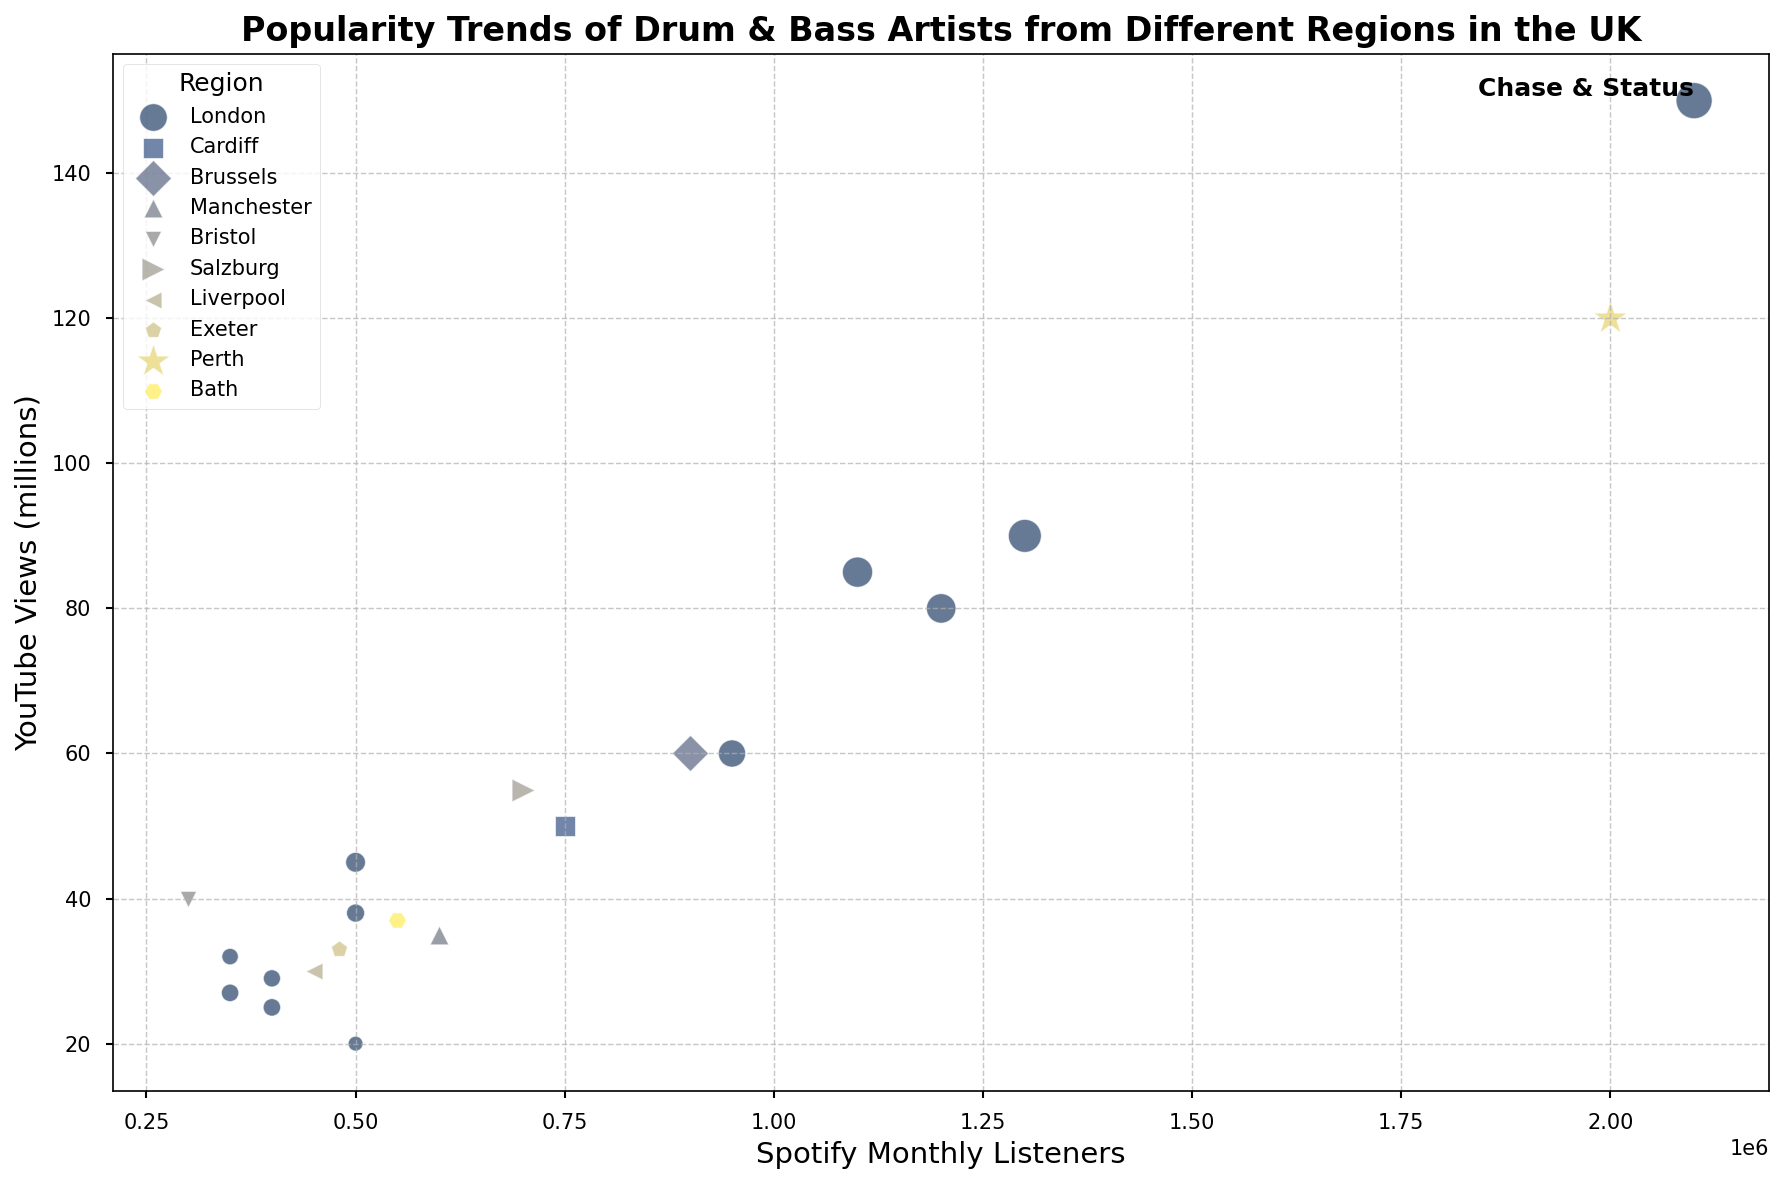What is the total number of Spotify Monthly Listeners for artists from London? First, identify all the artists from London. Their Spotify Monthly Listeners are: Chase & Status (2,100,000), Sub Focus (1,200,000), Hospital Records (500,000), Fabio & Grooverider (400,000), Goldie (500,000), Brookes Brothers (350,000), Wilkinson (1,300,000), Andy C (1,100,000), DJ Fresh (950,000), LTJ Bukem (350,000), London Elektricity (400,000). Summing these values: 2,100,000 + 1,200,000 + 500,000 + 400,000 + 500,000 + 350,000 + 1,300,000 + 1,100,000 + 950,000 + 350,000 + 400,000 = 9,150,000
Answer: 9,150,000 Which artist has more Instagram Followers, Wilkinson or Pendulum? Check the Instagram Followers for Wilkinson (250,000) and Pendulum (280,000). Compare both values and find that Pendulum has more followers.
Answer: Pendulum Do Chase & Status have more YouTube Views than High Contrast? Compare the YouTube Views for Chase & Status (150 million) and High Contrast (50 million). The value for Chase & Status is greater.
Answer: Yes Which region has the most artists represented in the plot? Identify the regions and count the number of artists from each: London (12), Cardiff (1), Brussels (1), Manchester (1), Bristol (1), Salzburg (1), Liverpool (1), Exeter (1), Bath (1), Perth (1). London has the most artists.
Answer: London What is the average number of Instagram Followers for artists from London? Calculate the total number of Instagram Followers for London artists: 300,000 (Chase & Status) + 200,000 (Sub Focus) + 50,000 (Hospital Records) + 70,000 (Fabio & Grooverider) + 90,000 (Goldie) + 62,000 (Brookes Brothers) + 250,000 (Wilkinson) + 210,000 (Andy C) + 170,000 (DJ Fresh) + 70,000 (LTJ Bukem) + 68,000 (London Elektricity) = 1,540,000. There are 11 artists from London. Divide the total by the number of artists: 1,540,000 / 11 ≈ 140,000
Answer: 140,000 Who has fewer Spotify Monthly Listeners, Danny Byrd or Fred V & Grafix? Compare the Spotify Monthly Listeners for Danny Byrd (550,000) and Fred V & Grafix (480,000). Fred V & Grafix has fewer listeners.
Answer: Fred V & Grafix Which artist from Cardiff has the highest YouTube Views? There is only one artist from Cardiff, High Contrast, whose YouTube Views are 50 million.
Answer: High Contrast Does Pendulum or Wilkinson have a larger marker size in the plot? Marker size is based on Instagram Followers. Pendulum has 280,000 followers; Wilkinson has 250,000 followers. Pendulum has a larger marker size.
Answer: Pendulum 